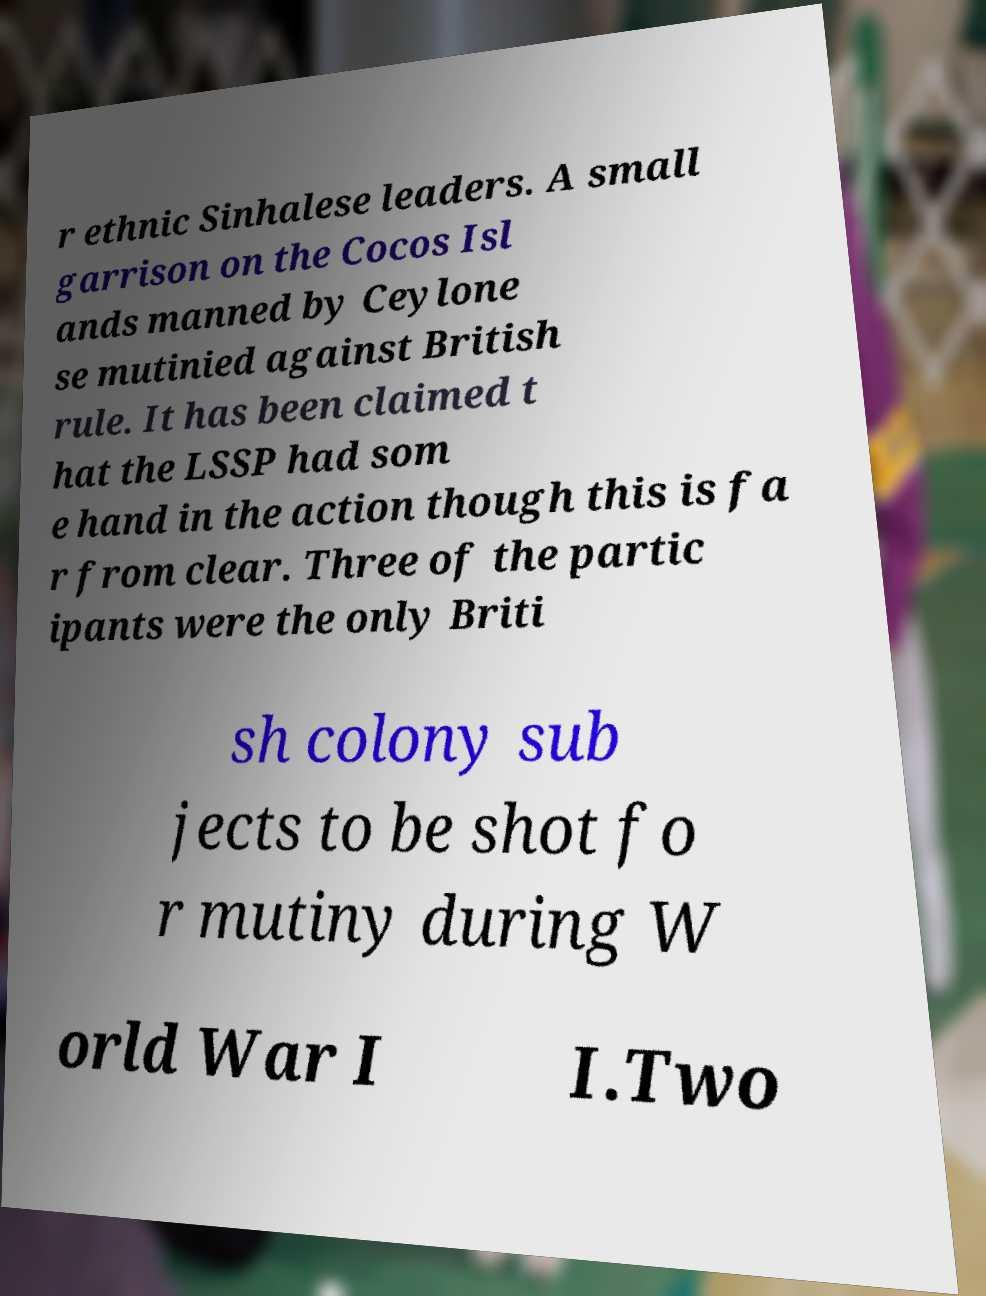Can you read and provide the text displayed in the image?This photo seems to have some interesting text. Can you extract and type it out for me? r ethnic Sinhalese leaders. A small garrison on the Cocos Isl ands manned by Ceylone se mutinied against British rule. It has been claimed t hat the LSSP had som e hand in the action though this is fa r from clear. Three of the partic ipants were the only Briti sh colony sub jects to be shot fo r mutiny during W orld War I I.Two 